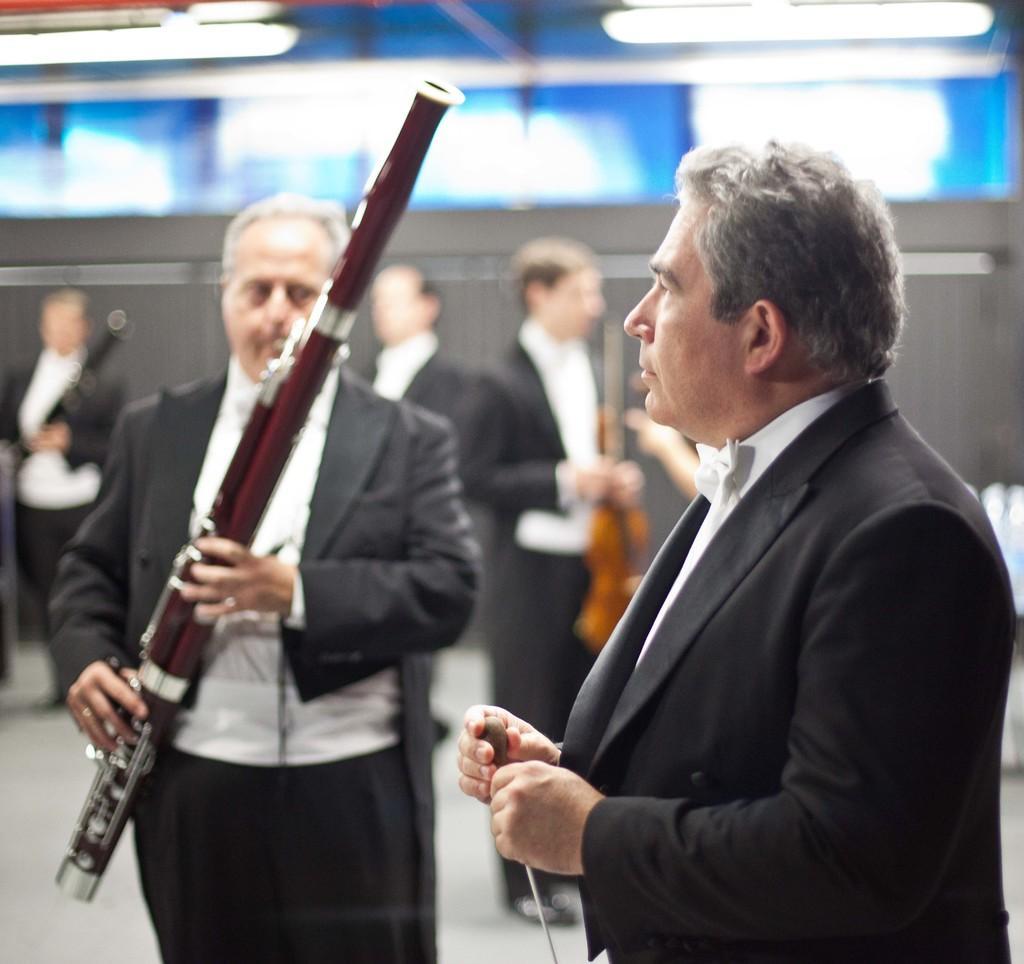How would you summarize this image in a sentence or two? In this image, I can see few people standing. They are holding different types of musical instruments. I think these are the lights. 